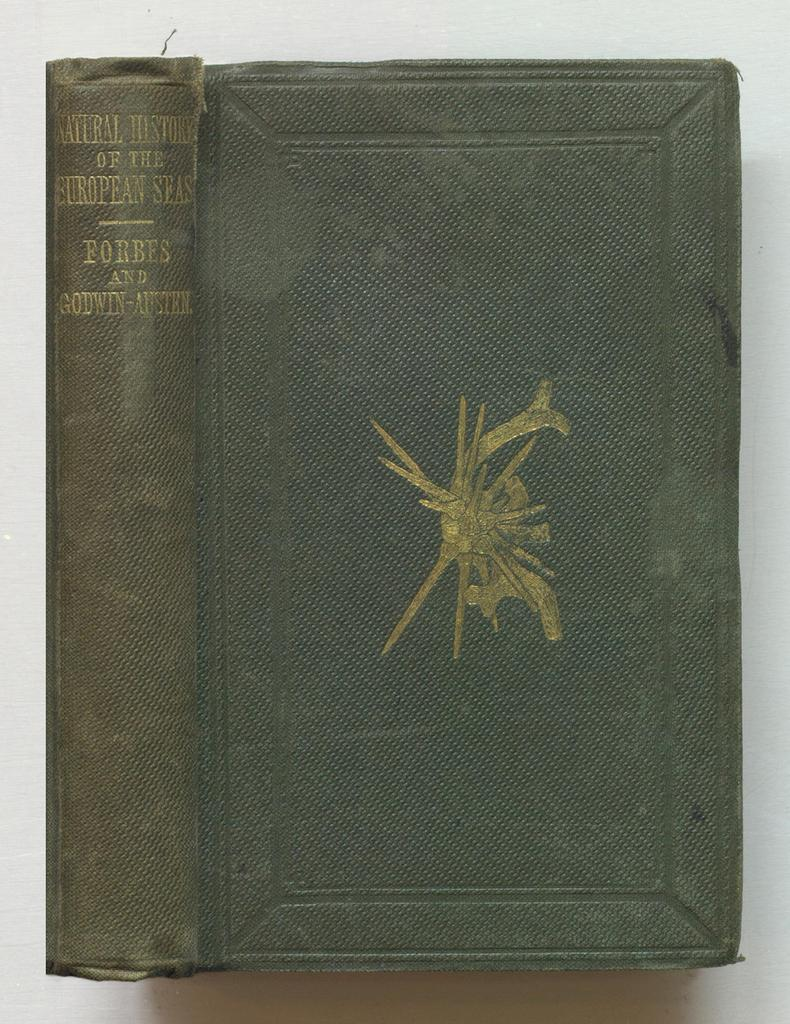What object is present in the image? The image contains a book. What type of dress is the man wearing in the image? There is no man or dress present in the image; it only contains a book. 